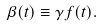Convert formula to latex. <formula><loc_0><loc_0><loc_500><loc_500>\beta ( t ) \equiv \gamma \, f ( t ) .</formula> 